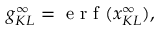<formula> <loc_0><loc_0><loc_500><loc_500>g _ { K L } ^ { \infty } = e r f ( x _ { K L } ^ { \infty } ) ,</formula> 